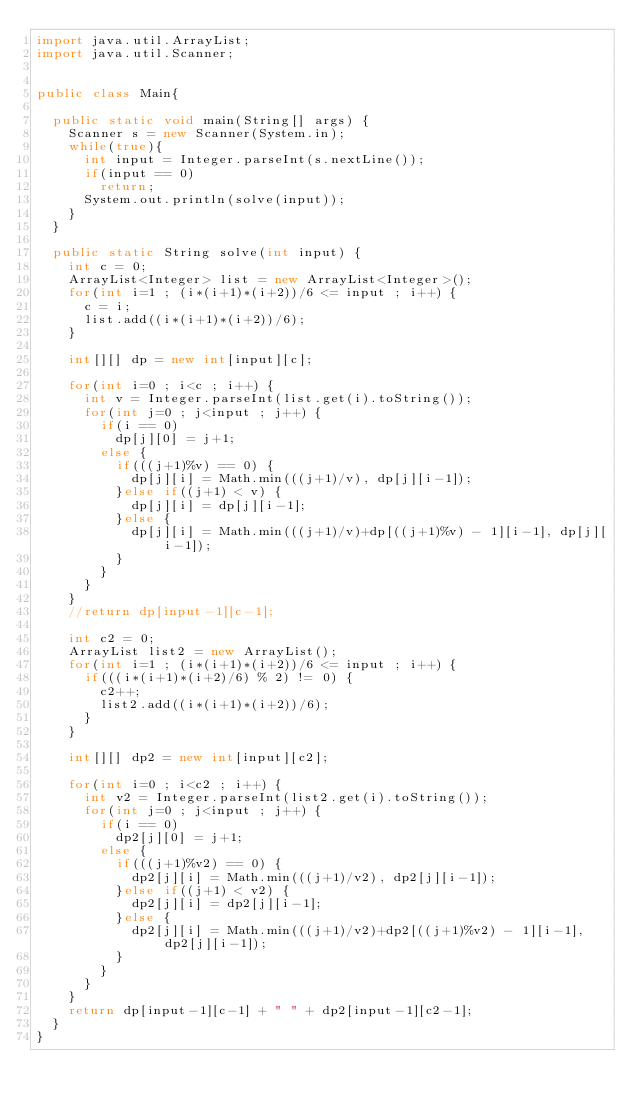Convert code to text. <code><loc_0><loc_0><loc_500><loc_500><_Java_>import java.util.ArrayList;
import java.util.Scanner;


public class Main{

	public static void main(String[] args) {
		Scanner s = new Scanner(System.in);
		while(true){
			int input = Integer.parseInt(s.nextLine());
			if(input == 0)
				return;
			System.out.println(solve(input));
		}
	}

	public static String solve(int input) {
		int c = 0;
		ArrayList<Integer> list = new ArrayList<Integer>();
		for(int i=1 ; (i*(i+1)*(i+2))/6 <= input ; i++) {
			c = i;
			list.add((i*(i+1)*(i+2))/6);
		}

		int[][] dp = new int[input][c];

		for(int i=0 ; i<c ; i++) {
			int v = Integer.parseInt(list.get(i).toString());
			for(int j=0 ; j<input ; j++) {
				if(i == 0)
					dp[j][0] = j+1;
				else {
					if(((j+1)%v) == 0) {
						dp[j][i] = Math.min(((j+1)/v), dp[j][i-1]);
					}else if((j+1) < v) {
						dp[j][i] = dp[j][i-1];
					}else {
						dp[j][i] = Math.min(((j+1)/v)+dp[((j+1)%v) - 1][i-1], dp[j][i-1]);
					}
				}
			}
		}
		//return dp[input-1][c-1];

		int c2 = 0;
		ArrayList list2 = new ArrayList();
		for(int i=1 ; (i*(i+1)*(i+2))/6 <= input ; i++) {
			if(((i*(i+1)*(i+2)/6) % 2) != 0) {
				c2++;
				list2.add((i*(i+1)*(i+2))/6);
			}
		}

		int[][] dp2 = new int[input][c2];

		for(int i=0 ; i<c2 ; i++) {
			int v2 = Integer.parseInt(list2.get(i).toString());
			for(int j=0 ; j<input ; j++) {
				if(i == 0)
					dp2[j][0] = j+1;
				else {
					if(((j+1)%v2) == 0) {
						dp2[j][i] = Math.min(((j+1)/v2), dp2[j][i-1]);
					}else if((j+1) < v2) {
						dp2[j][i] = dp2[j][i-1];
					}else {
						dp2[j][i] = Math.min(((j+1)/v2)+dp2[((j+1)%v2) - 1][i-1], dp2[j][i-1]);
					}
				}
			}
		}
		return dp[input-1][c-1] + " " + dp2[input-1][c2-1];
	}
}</code> 